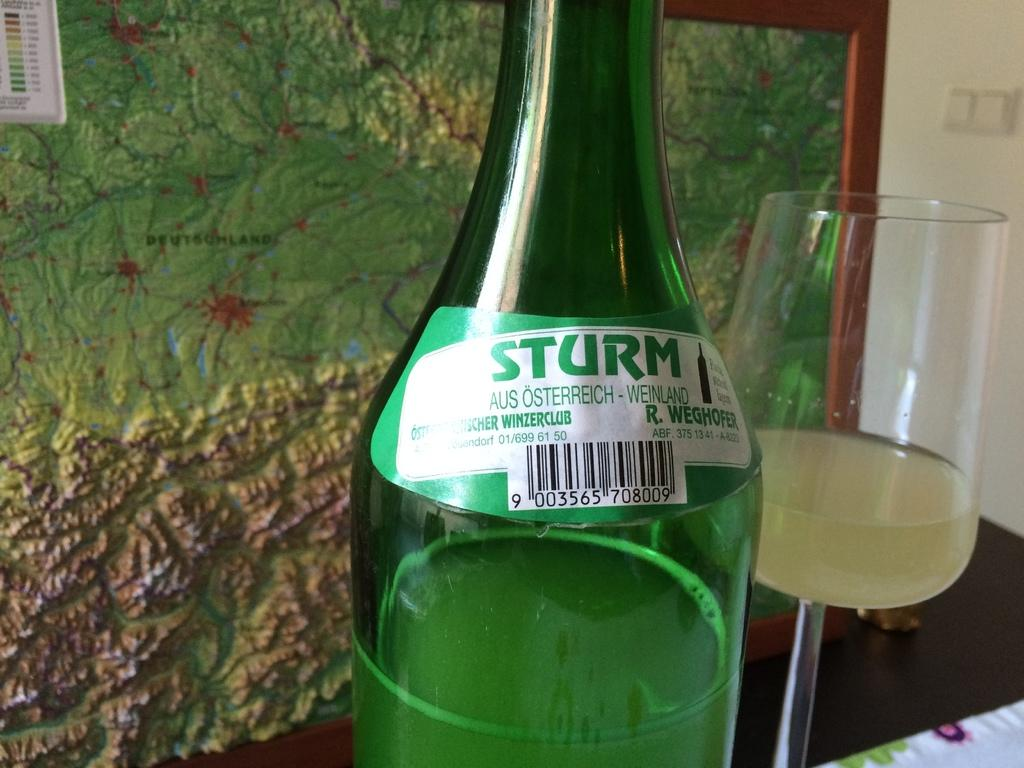<image>
Give a short and clear explanation of the subsequent image. A bottle of Sturm wine from winerzclub sits on a table in front of a map 